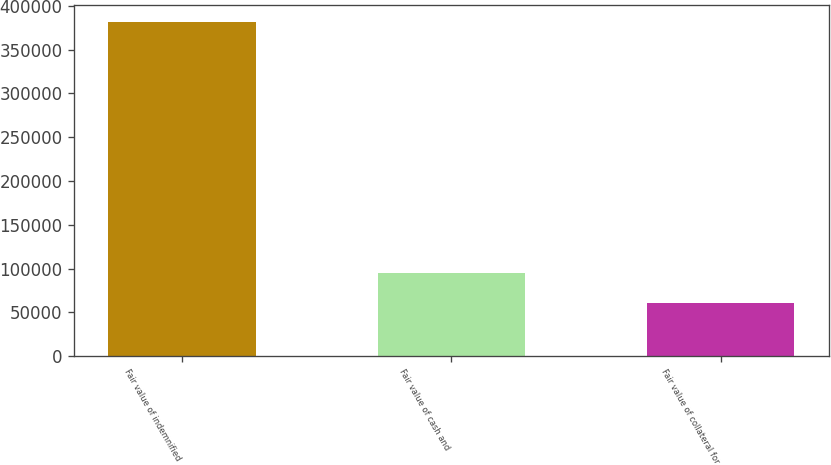<chart> <loc_0><loc_0><loc_500><loc_500><bar_chart><fcel>Fair value of indemnified<fcel>Fair value of cash and<fcel>Fair value of collateral for<nl><fcel>381817<fcel>95225.8<fcel>61270<nl></chart> 